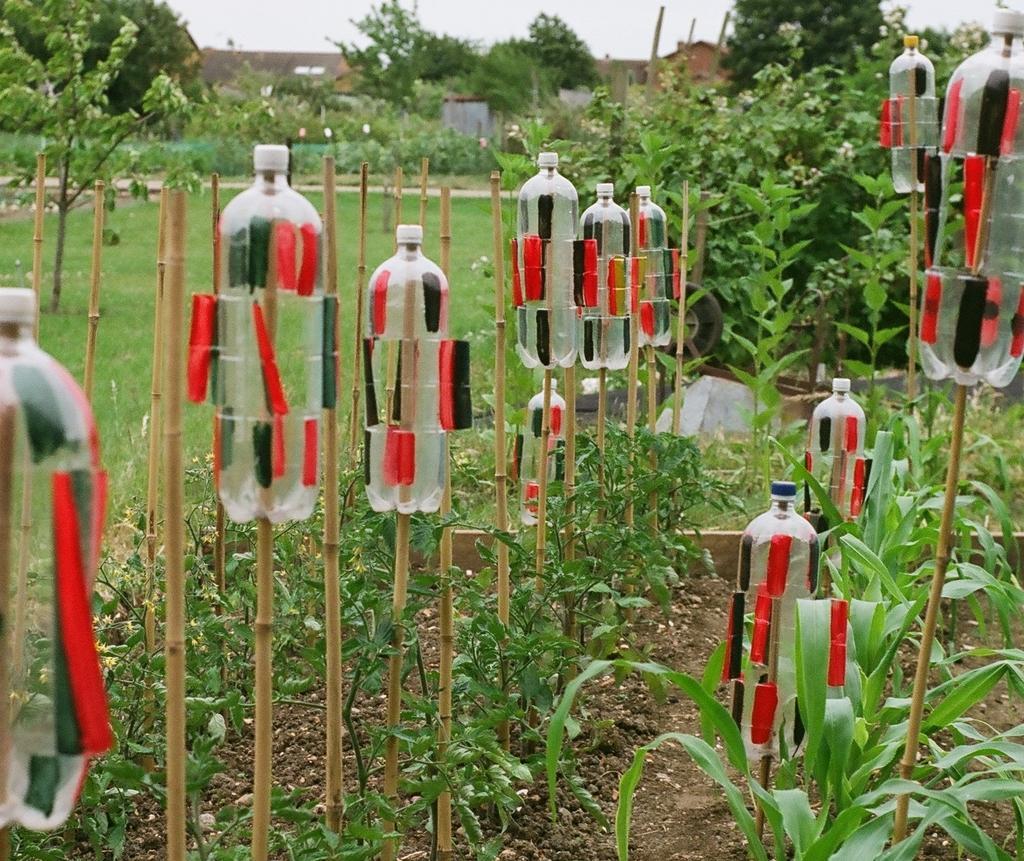How would you summarize this image in a sentence or two? There are group of trees which has a stick and a bottle attached to it and there are trees and buildings in the background and the ground is greenery. 